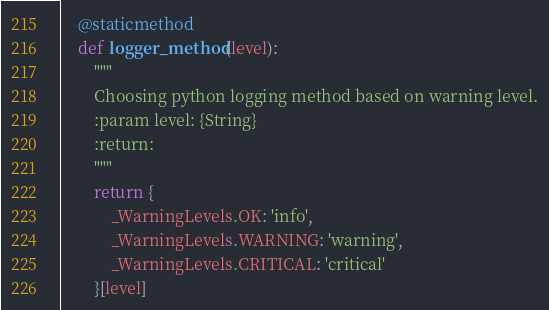<code> <loc_0><loc_0><loc_500><loc_500><_Python_>    @staticmethod
    def logger_method(level):
        """
        Choosing python logging method based on warning level.
        :param level: {String}
        :return:
        """
        return {
            _WarningLevels.OK: 'info',
            _WarningLevels.WARNING: 'warning',
            _WarningLevels.CRITICAL: 'critical'
        }[level]
</code> 